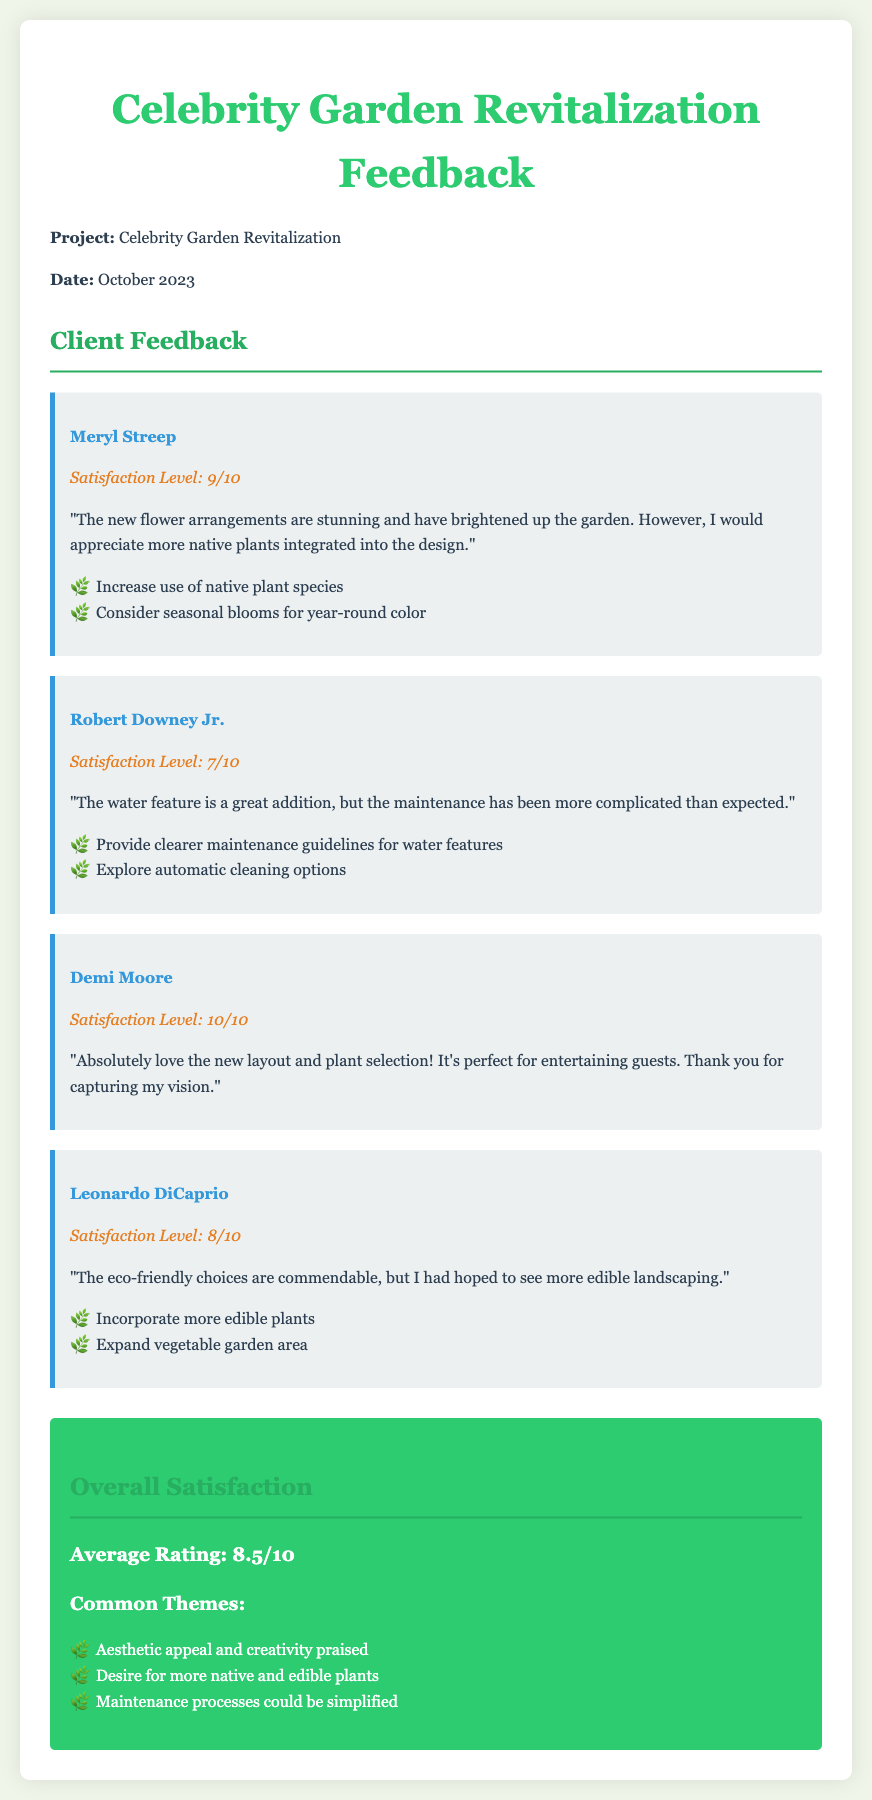What is the project title? The project title is specified in the document as "Celebrity Garden Revitalization."
Answer: Celebrity Garden Revitalization What is Meryl Streep's satisfaction level? Meryl Streep's satisfaction level is explicitly stated in the feedback section of the document.
Answer: 9/10 What maintenance aspect did Robert Downey Jr. find complicated? Robert Downey Jr. mentioned that the maintenance of the water feature was more complicated than expected.
Answer: Water feature Which client gave the highest satisfaction rating? The document lists the satisfaction ratings for each client, with the highest specifically noted.
Answer: Demi Moore What common theme is mentioned regarding plant choices? The common themes section highlights specific desires from clients about plant selections, referring to both native and edible plants.
Answer: More native and edible plants What rating does the overall satisfaction section reflect? The overall satisfaction section provides an average rating based on the client feedback documented.
Answer: 8.5/10 What feedback did Leonardo DiCaprio provide regarding the landscaping? Leonardo DiCaprio's feedback includes a desire for more edible landscaping, which is part of the reasoning behind his rating.
Answer: More edible landscaping 